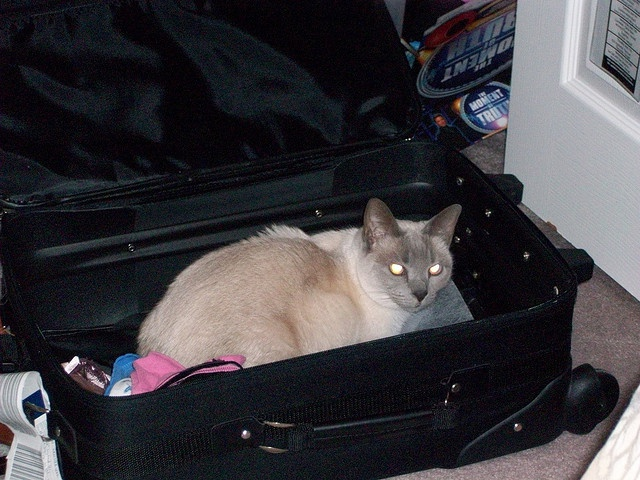Describe the objects in this image and their specific colors. I can see suitcase in black, darkgray, and gray tones and cat in black, darkgray, and gray tones in this image. 